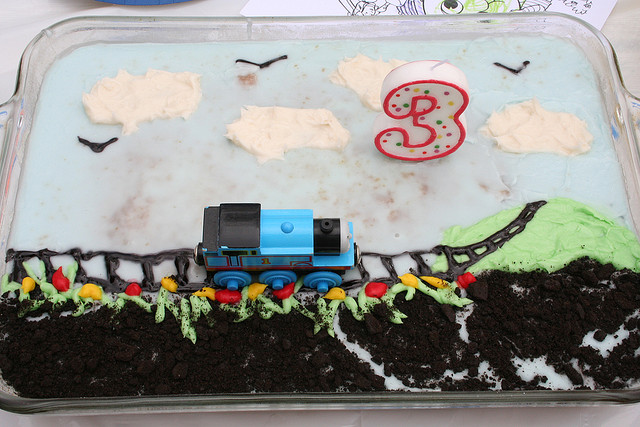Please extract the text content from this image. 3 